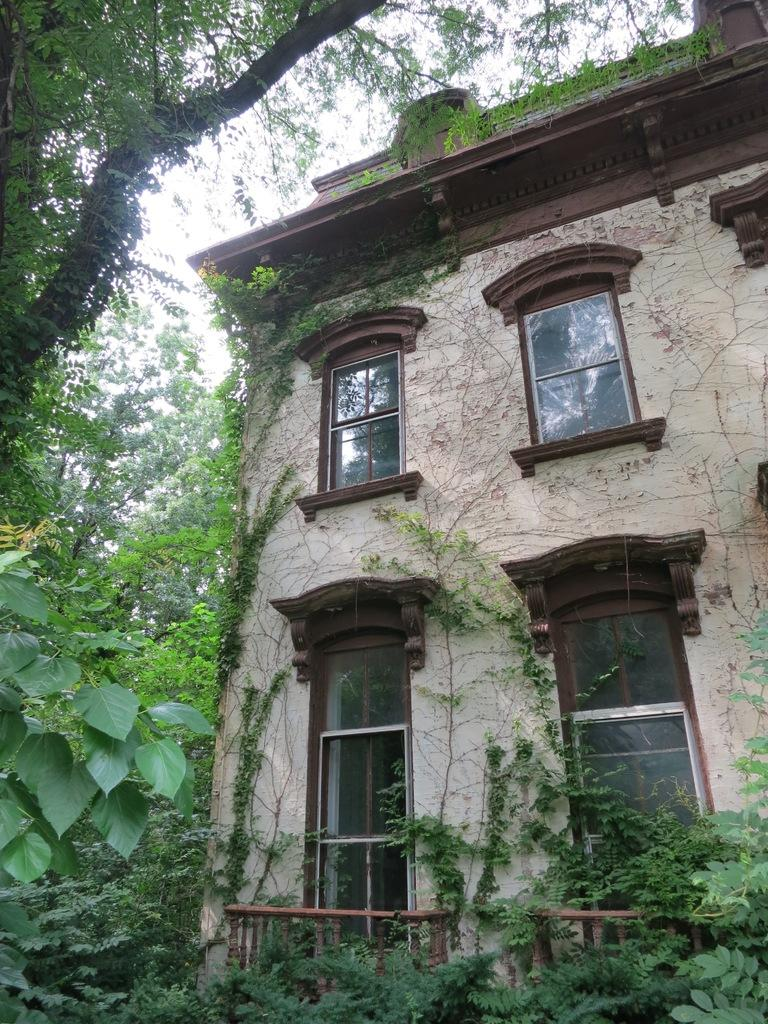What can be seen in the left corner of the image? There are trees and leaves on the left corner of the image. What type of structure is present in the image? There is a building with windows in the image. What material is used for the railing on the building? The building has a wooden railing. What is visible in the right corner of the image? There are trees on the right corner of the image. What is visible at the top of the image? The sky is visible at the top of the image. What type of connection error is shown in the image? There is no connection error present in the image; it features trees, a building, and the sky. Where is the pocket located in the image? There is no pocket present in the image. 